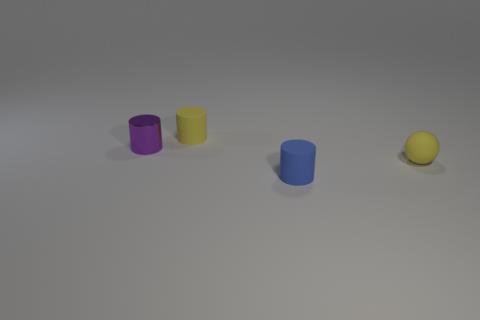Subtract all tiny blue matte cylinders. How many cylinders are left? 2 Subtract all blue cylinders. How many cylinders are left? 2 Subtract all cylinders. How many objects are left? 1 Add 3 cyan matte balls. How many objects exist? 7 Subtract 2 cylinders. How many cylinders are left? 1 Subtract all cyan cubes. How many purple cylinders are left? 1 Subtract all balls. Subtract all yellow rubber objects. How many objects are left? 1 Add 1 yellow balls. How many yellow balls are left? 2 Add 2 green shiny balls. How many green shiny balls exist? 2 Subtract 0 gray cylinders. How many objects are left? 4 